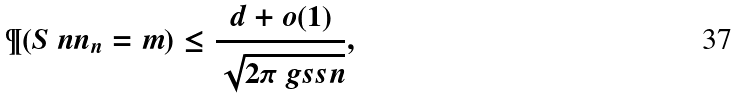<formula> <loc_0><loc_0><loc_500><loc_500>\P ( S \ n n _ { n } = m ) \leq \frac { d + o ( 1 ) } { \sqrt { 2 \pi \ g s s n } } ,</formula> 